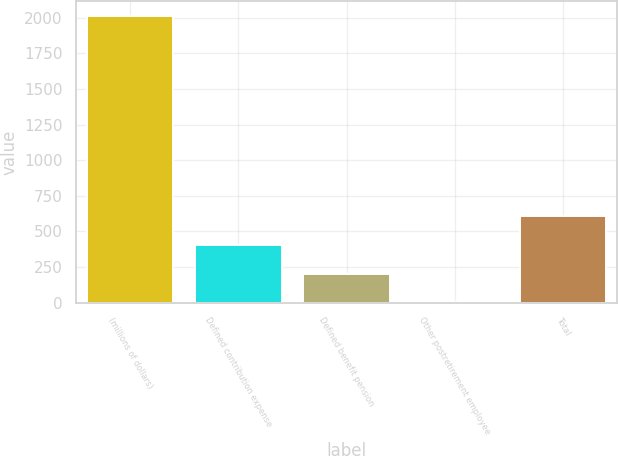Convert chart to OTSL. <chart><loc_0><loc_0><loc_500><loc_500><bar_chart><fcel>(millions of dollars)<fcel>Defined contribution expense<fcel>Defined benefit pension<fcel>Other postretirement employee<fcel>Total<nl><fcel>2014<fcel>405.44<fcel>204.37<fcel>3.3<fcel>606.51<nl></chart> 